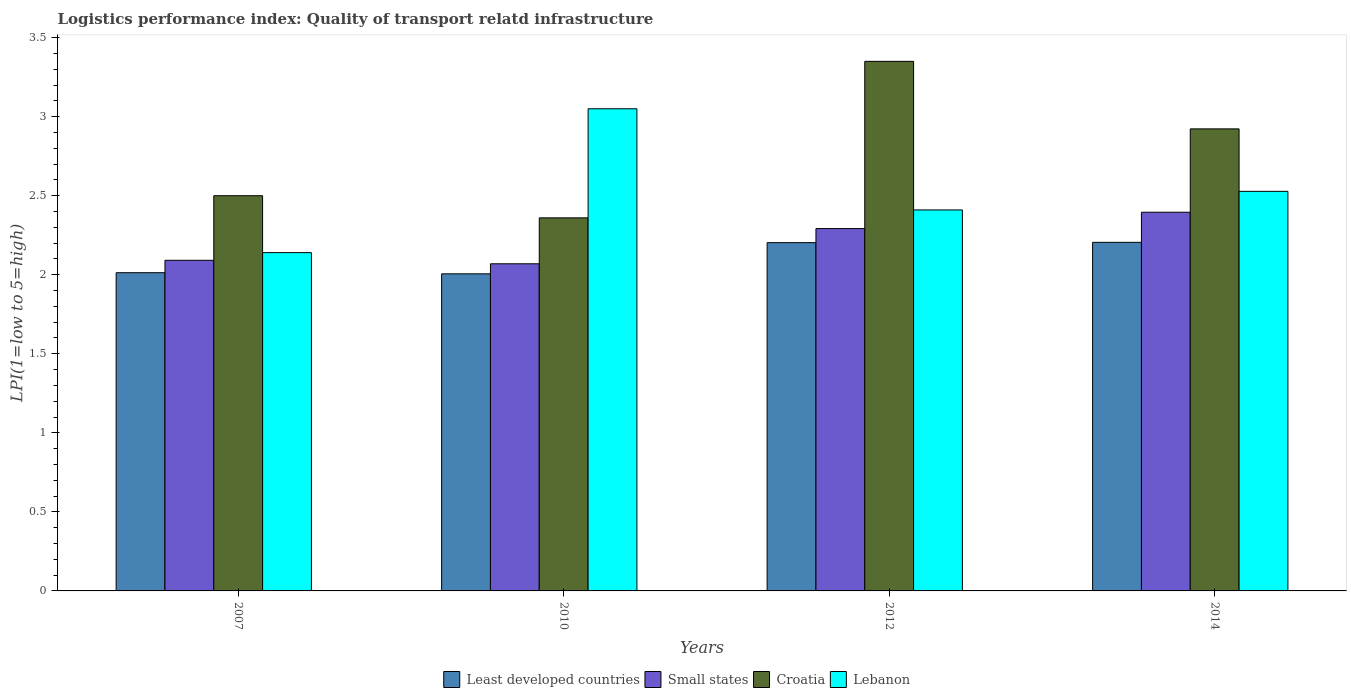In how many cases, is the number of bars for a given year not equal to the number of legend labels?
Your answer should be very brief. 0. What is the logistics performance index in Small states in 2012?
Offer a very short reply. 2.29. Across all years, what is the maximum logistics performance index in Small states?
Your response must be concise. 2.4. Across all years, what is the minimum logistics performance index in Lebanon?
Your answer should be very brief. 2.14. In which year was the logistics performance index in Lebanon maximum?
Offer a very short reply. 2010. What is the total logistics performance index in Lebanon in the graph?
Provide a short and direct response. 10.13. What is the difference between the logistics performance index in Croatia in 2007 and that in 2014?
Offer a very short reply. -0.42. What is the difference between the logistics performance index in Croatia in 2010 and the logistics performance index in Least developed countries in 2012?
Give a very brief answer. 0.16. What is the average logistics performance index in Lebanon per year?
Make the answer very short. 2.53. In the year 2014, what is the difference between the logistics performance index in Lebanon and logistics performance index in Least developed countries?
Your response must be concise. 0.32. In how many years, is the logistics performance index in Croatia greater than 2.5?
Your answer should be compact. 2. What is the ratio of the logistics performance index in Small states in 2007 to that in 2010?
Your answer should be compact. 1.01. Is the logistics performance index in Small states in 2010 less than that in 2014?
Ensure brevity in your answer.  Yes. Is the difference between the logistics performance index in Lebanon in 2007 and 2012 greater than the difference between the logistics performance index in Least developed countries in 2007 and 2012?
Provide a succinct answer. No. What is the difference between the highest and the second highest logistics performance index in Least developed countries?
Offer a very short reply. 0. What is the difference between the highest and the lowest logistics performance index in Croatia?
Offer a terse response. 0.99. In how many years, is the logistics performance index in Least developed countries greater than the average logistics performance index in Least developed countries taken over all years?
Keep it short and to the point. 2. Is it the case that in every year, the sum of the logistics performance index in Croatia and logistics performance index in Least developed countries is greater than the sum of logistics performance index in Lebanon and logistics performance index in Small states?
Your response must be concise. Yes. What does the 1st bar from the left in 2014 represents?
Your answer should be very brief. Least developed countries. What does the 1st bar from the right in 2007 represents?
Give a very brief answer. Lebanon. Is it the case that in every year, the sum of the logistics performance index in Croatia and logistics performance index in Lebanon is greater than the logistics performance index in Least developed countries?
Ensure brevity in your answer.  Yes. How many bars are there?
Make the answer very short. 16. Does the graph contain grids?
Provide a succinct answer. No. Where does the legend appear in the graph?
Offer a very short reply. Bottom center. What is the title of the graph?
Offer a very short reply. Logistics performance index: Quality of transport relatd infrastructure. Does "Guam" appear as one of the legend labels in the graph?
Provide a succinct answer. No. What is the label or title of the Y-axis?
Ensure brevity in your answer.  LPI(1=low to 5=high). What is the LPI(1=low to 5=high) in Least developed countries in 2007?
Ensure brevity in your answer.  2.01. What is the LPI(1=low to 5=high) of Small states in 2007?
Ensure brevity in your answer.  2.09. What is the LPI(1=low to 5=high) in Croatia in 2007?
Your response must be concise. 2.5. What is the LPI(1=low to 5=high) of Lebanon in 2007?
Your response must be concise. 2.14. What is the LPI(1=low to 5=high) in Least developed countries in 2010?
Your answer should be very brief. 2.01. What is the LPI(1=low to 5=high) in Small states in 2010?
Ensure brevity in your answer.  2.07. What is the LPI(1=low to 5=high) of Croatia in 2010?
Your answer should be compact. 2.36. What is the LPI(1=low to 5=high) of Lebanon in 2010?
Ensure brevity in your answer.  3.05. What is the LPI(1=low to 5=high) of Least developed countries in 2012?
Make the answer very short. 2.2. What is the LPI(1=low to 5=high) of Small states in 2012?
Keep it short and to the point. 2.29. What is the LPI(1=low to 5=high) in Croatia in 2012?
Give a very brief answer. 3.35. What is the LPI(1=low to 5=high) in Lebanon in 2012?
Make the answer very short. 2.41. What is the LPI(1=low to 5=high) in Least developed countries in 2014?
Provide a succinct answer. 2.21. What is the LPI(1=low to 5=high) in Small states in 2014?
Provide a short and direct response. 2.4. What is the LPI(1=low to 5=high) in Croatia in 2014?
Provide a short and direct response. 2.92. What is the LPI(1=low to 5=high) of Lebanon in 2014?
Your answer should be compact. 2.53. Across all years, what is the maximum LPI(1=low to 5=high) of Least developed countries?
Keep it short and to the point. 2.21. Across all years, what is the maximum LPI(1=low to 5=high) of Small states?
Your response must be concise. 2.4. Across all years, what is the maximum LPI(1=low to 5=high) of Croatia?
Give a very brief answer. 3.35. Across all years, what is the maximum LPI(1=low to 5=high) in Lebanon?
Offer a very short reply. 3.05. Across all years, what is the minimum LPI(1=low to 5=high) of Least developed countries?
Offer a very short reply. 2.01. Across all years, what is the minimum LPI(1=low to 5=high) in Small states?
Your answer should be very brief. 2.07. Across all years, what is the minimum LPI(1=low to 5=high) in Croatia?
Your answer should be very brief. 2.36. Across all years, what is the minimum LPI(1=low to 5=high) of Lebanon?
Make the answer very short. 2.14. What is the total LPI(1=low to 5=high) in Least developed countries in the graph?
Ensure brevity in your answer.  8.43. What is the total LPI(1=low to 5=high) in Small states in the graph?
Offer a very short reply. 8.85. What is the total LPI(1=low to 5=high) of Croatia in the graph?
Your answer should be very brief. 11.13. What is the total LPI(1=low to 5=high) in Lebanon in the graph?
Your answer should be compact. 10.13. What is the difference between the LPI(1=low to 5=high) of Least developed countries in 2007 and that in 2010?
Ensure brevity in your answer.  0.01. What is the difference between the LPI(1=low to 5=high) of Small states in 2007 and that in 2010?
Your answer should be very brief. 0.02. What is the difference between the LPI(1=low to 5=high) of Croatia in 2007 and that in 2010?
Provide a short and direct response. 0.14. What is the difference between the LPI(1=low to 5=high) of Lebanon in 2007 and that in 2010?
Give a very brief answer. -0.91. What is the difference between the LPI(1=low to 5=high) of Least developed countries in 2007 and that in 2012?
Your answer should be very brief. -0.19. What is the difference between the LPI(1=low to 5=high) in Small states in 2007 and that in 2012?
Offer a terse response. -0.2. What is the difference between the LPI(1=low to 5=high) of Croatia in 2007 and that in 2012?
Offer a terse response. -0.85. What is the difference between the LPI(1=low to 5=high) in Lebanon in 2007 and that in 2012?
Your answer should be compact. -0.27. What is the difference between the LPI(1=low to 5=high) in Least developed countries in 2007 and that in 2014?
Ensure brevity in your answer.  -0.19. What is the difference between the LPI(1=low to 5=high) of Small states in 2007 and that in 2014?
Provide a short and direct response. -0.3. What is the difference between the LPI(1=low to 5=high) of Croatia in 2007 and that in 2014?
Give a very brief answer. -0.42. What is the difference between the LPI(1=low to 5=high) in Lebanon in 2007 and that in 2014?
Your answer should be very brief. -0.39. What is the difference between the LPI(1=low to 5=high) of Least developed countries in 2010 and that in 2012?
Offer a very short reply. -0.2. What is the difference between the LPI(1=low to 5=high) of Small states in 2010 and that in 2012?
Give a very brief answer. -0.22. What is the difference between the LPI(1=low to 5=high) of Croatia in 2010 and that in 2012?
Make the answer very short. -0.99. What is the difference between the LPI(1=low to 5=high) in Lebanon in 2010 and that in 2012?
Provide a short and direct response. 0.64. What is the difference between the LPI(1=low to 5=high) in Least developed countries in 2010 and that in 2014?
Ensure brevity in your answer.  -0.2. What is the difference between the LPI(1=low to 5=high) of Small states in 2010 and that in 2014?
Your answer should be compact. -0.33. What is the difference between the LPI(1=low to 5=high) in Croatia in 2010 and that in 2014?
Keep it short and to the point. -0.56. What is the difference between the LPI(1=low to 5=high) of Lebanon in 2010 and that in 2014?
Your answer should be very brief. 0.52. What is the difference between the LPI(1=low to 5=high) in Least developed countries in 2012 and that in 2014?
Keep it short and to the point. -0. What is the difference between the LPI(1=low to 5=high) in Small states in 2012 and that in 2014?
Provide a short and direct response. -0.1. What is the difference between the LPI(1=low to 5=high) of Croatia in 2012 and that in 2014?
Make the answer very short. 0.43. What is the difference between the LPI(1=low to 5=high) of Lebanon in 2012 and that in 2014?
Ensure brevity in your answer.  -0.12. What is the difference between the LPI(1=low to 5=high) in Least developed countries in 2007 and the LPI(1=low to 5=high) in Small states in 2010?
Your answer should be very brief. -0.06. What is the difference between the LPI(1=low to 5=high) of Least developed countries in 2007 and the LPI(1=low to 5=high) of Croatia in 2010?
Provide a short and direct response. -0.35. What is the difference between the LPI(1=low to 5=high) of Least developed countries in 2007 and the LPI(1=low to 5=high) of Lebanon in 2010?
Your answer should be very brief. -1.04. What is the difference between the LPI(1=low to 5=high) of Small states in 2007 and the LPI(1=low to 5=high) of Croatia in 2010?
Provide a short and direct response. -0.27. What is the difference between the LPI(1=low to 5=high) in Small states in 2007 and the LPI(1=low to 5=high) in Lebanon in 2010?
Ensure brevity in your answer.  -0.96. What is the difference between the LPI(1=low to 5=high) of Croatia in 2007 and the LPI(1=low to 5=high) of Lebanon in 2010?
Provide a short and direct response. -0.55. What is the difference between the LPI(1=low to 5=high) in Least developed countries in 2007 and the LPI(1=low to 5=high) in Small states in 2012?
Make the answer very short. -0.28. What is the difference between the LPI(1=low to 5=high) in Least developed countries in 2007 and the LPI(1=low to 5=high) in Croatia in 2012?
Give a very brief answer. -1.34. What is the difference between the LPI(1=low to 5=high) of Least developed countries in 2007 and the LPI(1=low to 5=high) of Lebanon in 2012?
Your answer should be compact. -0.4. What is the difference between the LPI(1=low to 5=high) in Small states in 2007 and the LPI(1=low to 5=high) in Croatia in 2012?
Offer a very short reply. -1.26. What is the difference between the LPI(1=low to 5=high) of Small states in 2007 and the LPI(1=low to 5=high) of Lebanon in 2012?
Your answer should be very brief. -0.32. What is the difference between the LPI(1=low to 5=high) in Croatia in 2007 and the LPI(1=low to 5=high) in Lebanon in 2012?
Your response must be concise. 0.09. What is the difference between the LPI(1=low to 5=high) of Least developed countries in 2007 and the LPI(1=low to 5=high) of Small states in 2014?
Provide a succinct answer. -0.38. What is the difference between the LPI(1=low to 5=high) in Least developed countries in 2007 and the LPI(1=low to 5=high) in Croatia in 2014?
Ensure brevity in your answer.  -0.91. What is the difference between the LPI(1=low to 5=high) of Least developed countries in 2007 and the LPI(1=low to 5=high) of Lebanon in 2014?
Your answer should be very brief. -0.51. What is the difference between the LPI(1=low to 5=high) of Small states in 2007 and the LPI(1=low to 5=high) of Croatia in 2014?
Your response must be concise. -0.83. What is the difference between the LPI(1=low to 5=high) in Small states in 2007 and the LPI(1=low to 5=high) in Lebanon in 2014?
Keep it short and to the point. -0.44. What is the difference between the LPI(1=low to 5=high) in Croatia in 2007 and the LPI(1=low to 5=high) in Lebanon in 2014?
Your response must be concise. -0.03. What is the difference between the LPI(1=low to 5=high) of Least developed countries in 2010 and the LPI(1=low to 5=high) of Small states in 2012?
Ensure brevity in your answer.  -0.29. What is the difference between the LPI(1=low to 5=high) of Least developed countries in 2010 and the LPI(1=low to 5=high) of Croatia in 2012?
Your response must be concise. -1.34. What is the difference between the LPI(1=low to 5=high) of Least developed countries in 2010 and the LPI(1=low to 5=high) of Lebanon in 2012?
Your answer should be compact. -0.4. What is the difference between the LPI(1=low to 5=high) of Small states in 2010 and the LPI(1=low to 5=high) of Croatia in 2012?
Offer a very short reply. -1.28. What is the difference between the LPI(1=low to 5=high) of Small states in 2010 and the LPI(1=low to 5=high) of Lebanon in 2012?
Your answer should be compact. -0.34. What is the difference between the LPI(1=low to 5=high) in Least developed countries in 2010 and the LPI(1=low to 5=high) in Small states in 2014?
Your response must be concise. -0.39. What is the difference between the LPI(1=low to 5=high) of Least developed countries in 2010 and the LPI(1=low to 5=high) of Croatia in 2014?
Your response must be concise. -0.92. What is the difference between the LPI(1=low to 5=high) of Least developed countries in 2010 and the LPI(1=low to 5=high) of Lebanon in 2014?
Make the answer very short. -0.52. What is the difference between the LPI(1=low to 5=high) in Small states in 2010 and the LPI(1=low to 5=high) in Croatia in 2014?
Your response must be concise. -0.85. What is the difference between the LPI(1=low to 5=high) of Small states in 2010 and the LPI(1=low to 5=high) of Lebanon in 2014?
Offer a terse response. -0.46. What is the difference between the LPI(1=low to 5=high) in Croatia in 2010 and the LPI(1=low to 5=high) in Lebanon in 2014?
Ensure brevity in your answer.  -0.17. What is the difference between the LPI(1=low to 5=high) in Least developed countries in 2012 and the LPI(1=low to 5=high) in Small states in 2014?
Keep it short and to the point. -0.19. What is the difference between the LPI(1=low to 5=high) in Least developed countries in 2012 and the LPI(1=low to 5=high) in Croatia in 2014?
Ensure brevity in your answer.  -0.72. What is the difference between the LPI(1=low to 5=high) of Least developed countries in 2012 and the LPI(1=low to 5=high) of Lebanon in 2014?
Make the answer very short. -0.32. What is the difference between the LPI(1=low to 5=high) in Small states in 2012 and the LPI(1=low to 5=high) in Croatia in 2014?
Offer a very short reply. -0.63. What is the difference between the LPI(1=low to 5=high) in Small states in 2012 and the LPI(1=low to 5=high) in Lebanon in 2014?
Your answer should be very brief. -0.24. What is the difference between the LPI(1=low to 5=high) of Croatia in 2012 and the LPI(1=low to 5=high) of Lebanon in 2014?
Ensure brevity in your answer.  0.82. What is the average LPI(1=low to 5=high) in Least developed countries per year?
Offer a terse response. 2.11. What is the average LPI(1=low to 5=high) in Small states per year?
Your response must be concise. 2.21. What is the average LPI(1=low to 5=high) of Croatia per year?
Make the answer very short. 2.78. What is the average LPI(1=low to 5=high) of Lebanon per year?
Your response must be concise. 2.53. In the year 2007, what is the difference between the LPI(1=low to 5=high) in Least developed countries and LPI(1=low to 5=high) in Small states?
Offer a very short reply. -0.08. In the year 2007, what is the difference between the LPI(1=low to 5=high) in Least developed countries and LPI(1=low to 5=high) in Croatia?
Provide a short and direct response. -0.49. In the year 2007, what is the difference between the LPI(1=low to 5=high) in Least developed countries and LPI(1=low to 5=high) in Lebanon?
Keep it short and to the point. -0.13. In the year 2007, what is the difference between the LPI(1=low to 5=high) of Small states and LPI(1=low to 5=high) of Croatia?
Give a very brief answer. -0.41. In the year 2007, what is the difference between the LPI(1=low to 5=high) of Small states and LPI(1=low to 5=high) of Lebanon?
Your answer should be very brief. -0.05. In the year 2007, what is the difference between the LPI(1=low to 5=high) in Croatia and LPI(1=low to 5=high) in Lebanon?
Your answer should be compact. 0.36. In the year 2010, what is the difference between the LPI(1=low to 5=high) in Least developed countries and LPI(1=low to 5=high) in Small states?
Ensure brevity in your answer.  -0.06. In the year 2010, what is the difference between the LPI(1=low to 5=high) of Least developed countries and LPI(1=low to 5=high) of Croatia?
Provide a succinct answer. -0.35. In the year 2010, what is the difference between the LPI(1=low to 5=high) of Least developed countries and LPI(1=low to 5=high) of Lebanon?
Keep it short and to the point. -1.04. In the year 2010, what is the difference between the LPI(1=low to 5=high) of Small states and LPI(1=low to 5=high) of Croatia?
Your response must be concise. -0.29. In the year 2010, what is the difference between the LPI(1=low to 5=high) of Small states and LPI(1=low to 5=high) of Lebanon?
Keep it short and to the point. -0.98. In the year 2010, what is the difference between the LPI(1=low to 5=high) in Croatia and LPI(1=low to 5=high) in Lebanon?
Keep it short and to the point. -0.69. In the year 2012, what is the difference between the LPI(1=low to 5=high) in Least developed countries and LPI(1=low to 5=high) in Small states?
Your answer should be compact. -0.09. In the year 2012, what is the difference between the LPI(1=low to 5=high) in Least developed countries and LPI(1=low to 5=high) in Croatia?
Provide a short and direct response. -1.15. In the year 2012, what is the difference between the LPI(1=low to 5=high) in Least developed countries and LPI(1=low to 5=high) in Lebanon?
Your response must be concise. -0.21. In the year 2012, what is the difference between the LPI(1=low to 5=high) in Small states and LPI(1=low to 5=high) in Croatia?
Offer a terse response. -1.06. In the year 2012, what is the difference between the LPI(1=low to 5=high) of Small states and LPI(1=low to 5=high) of Lebanon?
Give a very brief answer. -0.12. In the year 2014, what is the difference between the LPI(1=low to 5=high) in Least developed countries and LPI(1=low to 5=high) in Small states?
Make the answer very short. -0.19. In the year 2014, what is the difference between the LPI(1=low to 5=high) in Least developed countries and LPI(1=low to 5=high) in Croatia?
Offer a terse response. -0.72. In the year 2014, what is the difference between the LPI(1=low to 5=high) of Least developed countries and LPI(1=low to 5=high) of Lebanon?
Your answer should be compact. -0.32. In the year 2014, what is the difference between the LPI(1=low to 5=high) in Small states and LPI(1=low to 5=high) in Croatia?
Provide a short and direct response. -0.53. In the year 2014, what is the difference between the LPI(1=low to 5=high) of Small states and LPI(1=low to 5=high) of Lebanon?
Give a very brief answer. -0.13. In the year 2014, what is the difference between the LPI(1=low to 5=high) in Croatia and LPI(1=low to 5=high) in Lebanon?
Offer a very short reply. 0.4. What is the ratio of the LPI(1=low to 5=high) of Small states in 2007 to that in 2010?
Provide a short and direct response. 1.01. What is the ratio of the LPI(1=low to 5=high) of Croatia in 2007 to that in 2010?
Keep it short and to the point. 1.06. What is the ratio of the LPI(1=low to 5=high) in Lebanon in 2007 to that in 2010?
Provide a short and direct response. 0.7. What is the ratio of the LPI(1=low to 5=high) of Least developed countries in 2007 to that in 2012?
Provide a succinct answer. 0.91. What is the ratio of the LPI(1=low to 5=high) in Small states in 2007 to that in 2012?
Your answer should be compact. 0.91. What is the ratio of the LPI(1=low to 5=high) in Croatia in 2007 to that in 2012?
Offer a very short reply. 0.75. What is the ratio of the LPI(1=low to 5=high) in Lebanon in 2007 to that in 2012?
Your answer should be compact. 0.89. What is the ratio of the LPI(1=low to 5=high) of Least developed countries in 2007 to that in 2014?
Keep it short and to the point. 0.91. What is the ratio of the LPI(1=low to 5=high) of Small states in 2007 to that in 2014?
Your answer should be compact. 0.87. What is the ratio of the LPI(1=low to 5=high) in Croatia in 2007 to that in 2014?
Provide a succinct answer. 0.86. What is the ratio of the LPI(1=low to 5=high) of Lebanon in 2007 to that in 2014?
Offer a very short reply. 0.85. What is the ratio of the LPI(1=low to 5=high) in Least developed countries in 2010 to that in 2012?
Keep it short and to the point. 0.91. What is the ratio of the LPI(1=low to 5=high) of Small states in 2010 to that in 2012?
Your response must be concise. 0.9. What is the ratio of the LPI(1=low to 5=high) in Croatia in 2010 to that in 2012?
Your response must be concise. 0.7. What is the ratio of the LPI(1=low to 5=high) of Lebanon in 2010 to that in 2012?
Provide a succinct answer. 1.27. What is the ratio of the LPI(1=low to 5=high) of Least developed countries in 2010 to that in 2014?
Give a very brief answer. 0.91. What is the ratio of the LPI(1=low to 5=high) in Small states in 2010 to that in 2014?
Your answer should be very brief. 0.86. What is the ratio of the LPI(1=low to 5=high) of Croatia in 2010 to that in 2014?
Your answer should be very brief. 0.81. What is the ratio of the LPI(1=low to 5=high) in Lebanon in 2010 to that in 2014?
Keep it short and to the point. 1.21. What is the ratio of the LPI(1=low to 5=high) in Least developed countries in 2012 to that in 2014?
Ensure brevity in your answer.  1. What is the ratio of the LPI(1=low to 5=high) of Small states in 2012 to that in 2014?
Your answer should be very brief. 0.96. What is the ratio of the LPI(1=low to 5=high) of Croatia in 2012 to that in 2014?
Your answer should be very brief. 1.15. What is the ratio of the LPI(1=low to 5=high) of Lebanon in 2012 to that in 2014?
Ensure brevity in your answer.  0.95. What is the difference between the highest and the second highest LPI(1=low to 5=high) in Least developed countries?
Give a very brief answer. 0. What is the difference between the highest and the second highest LPI(1=low to 5=high) of Small states?
Your response must be concise. 0.1. What is the difference between the highest and the second highest LPI(1=low to 5=high) of Croatia?
Give a very brief answer. 0.43. What is the difference between the highest and the second highest LPI(1=low to 5=high) in Lebanon?
Make the answer very short. 0.52. What is the difference between the highest and the lowest LPI(1=low to 5=high) in Least developed countries?
Make the answer very short. 0.2. What is the difference between the highest and the lowest LPI(1=low to 5=high) of Small states?
Make the answer very short. 0.33. What is the difference between the highest and the lowest LPI(1=low to 5=high) of Croatia?
Give a very brief answer. 0.99. What is the difference between the highest and the lowest LPI(1=low to 5=high) of Lebanon?
Ensure brevity in your answer.  0.91. 